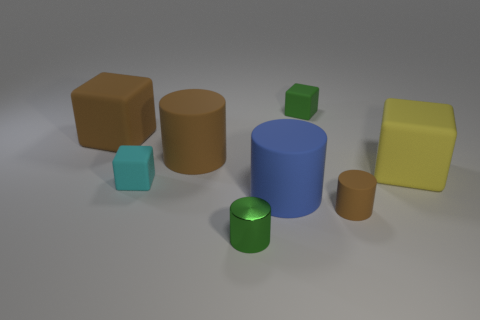What is the green thing in front of the brown cylinder behind the large thing in front of the big yellow rubber block made of?
Your response must be concise. Metal. Are there any other things that have the same material as the green cylinder?
Provide a short and direct response. No. Does the small green thing to the right of the small green metallic thing have the same shape as the tiny rubber object left of the green metallic cylinder?
Provide a short and direct response. Yes. Are there fewer small brown rubber objects behind the green metallic cylinder than shiny cylinders?
Your answer should be very brief. No. How many matte objects are the same color as the tiny metallic object?
Ensure brevity in your answer.  1. There is a brown rubber object on the left side of the large brown matte cylinder; what is its size?
Your answer should be compact. Large. What shape is the green thing to the right of the big cylinder that is on the right side of the small green cylinder that is on the right side of the big brown block?
Provide a short and direct response. Cube. There is a object that is both in front of the large blue matte cylinder and behind the green metal cylinder; what is its shape?
Provide a succinct answer. Cylinder. Is there a brown matte cylinder that has the same size as the blue object?
Ensure brevity in your answer.  Yes. Does the tiny green thing behind the small cyan rubber block have the same shape as the tiny brown matte thing?
Offer a terse response. No. 